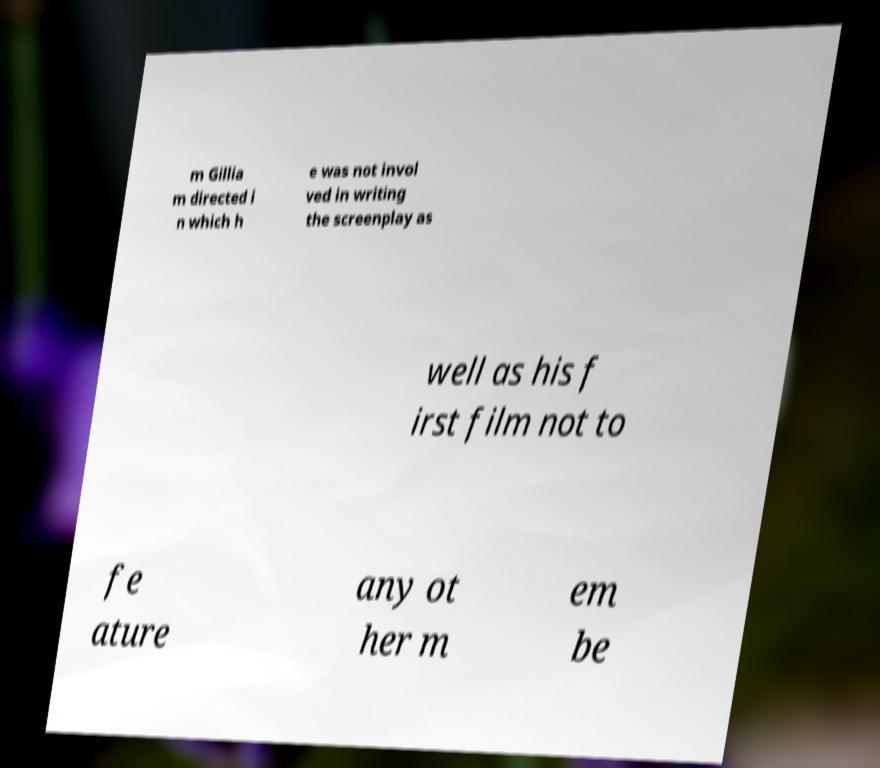Can you accurately transcribe the text from the provided image for me? m Gillia m directed i n which h e was not invol ved in writing the screenplay as well as his f irst film not to fe ature any ot her m em be 